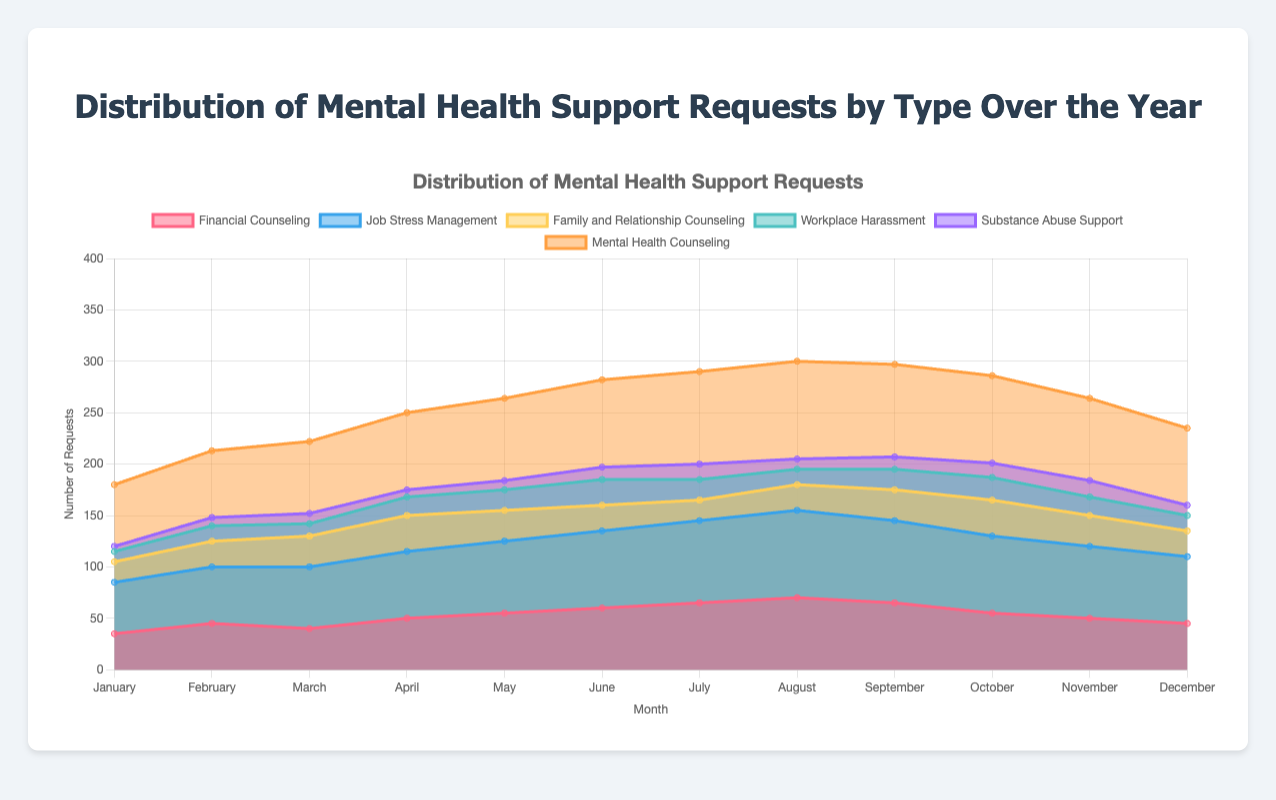What is the title of the chart? The title is typically found at the top of the chart, providing a summary of the visualized data. In this case, the title is visible as "Distribution of Mental Health Support Requests by Type Over the Year."
Answer: Distribution of Mental Health Support Requests by Type Over the Year Which type of support request had the highest number in January? By examining the height of the areas in the chart for January, we can see which type has the largest value. The tallest area in January corresponds to "Mental Health Counseling."
Answer: Mental Health Counseling What is the range (difference between the highest and lowest values) of support requests for Family and Relationship Counseling over the year? The highest number for Family and Relationship Counseling is 35, and the lowest is 20. The range is calculated as 35 - 20.
Answer: 15 How do the requests for Substance Abuse Support compare from May to November? To compare, look at the points on the chart for Substance Abuse Support in May and November. In May, the value is 9 and in November it is 16. Therefore, requests increased from 9 to 16.
Answer: Increased Which type of support request consistently increased from January to August? By observing the trend lines for each support request, we see that "Mental Health Counseling" shows a continuous increase from January (60) to August (95).
Answer: Mental Health Counseling When did Financial Counseling peak? Identify the highest point in the area corresponding to Financial Counseling throughout the months, which is 70 in August.
Answer: August During which month did Job Stress Management and Financial Counseling reach equal requests? We need to find the month where the heights of Job Stress Management and Financial Counseling are equal. This occurs in October, where both are at 55.
Answer: October What is the difference in the number of Mental Health Counseling requests between June and December? For June, the value is 85, and for December, it is 75. The difference is calculated as 85 - 75.
Answer: 10 Which month saw the highest combined number of support requests across all types? Summing the values for each type of request per month, August shows the highest combined number. We calculate sum(70 + 85 + 25 + 15 + 10 + 95) = 300.
Answer: August 